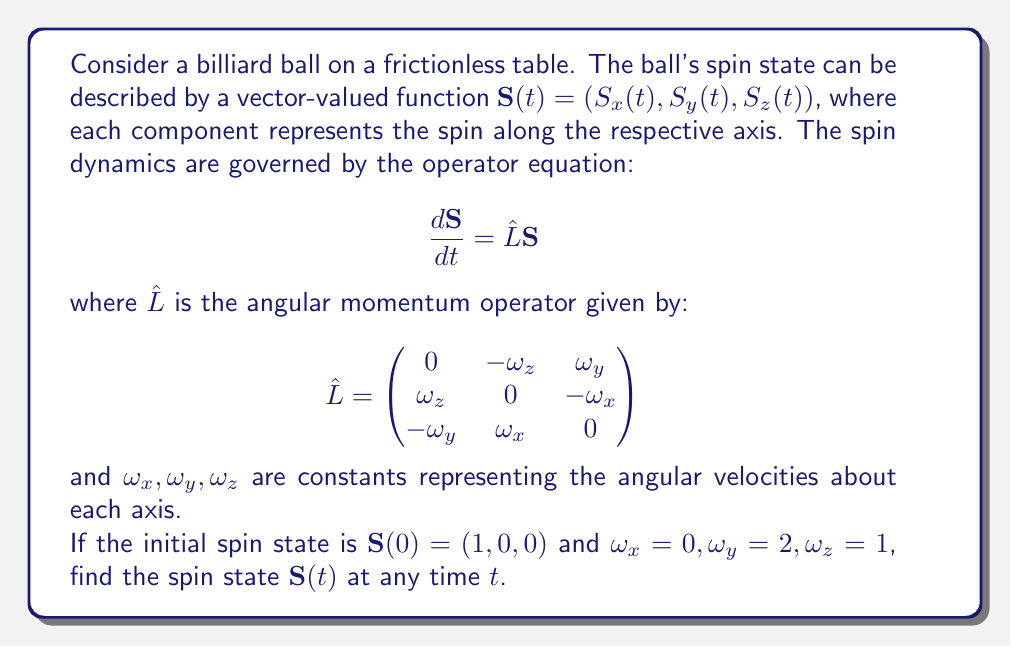Show me your answer to this math problem. To solve this problem, we need to follow these steps:

1) First, we need to write out the operator equation for our specific case:

   $$\frac{d}{dt}\begin{pmatrix} S_x \\ S_y \\ S_z \end{pmatrix} = \begin{pmatrix}
   0 & -1 & 2 \\
   1 & 0 & 0 \\
   -2 & 0 & 0
   \end{pmatrix}\begin{pmatrix} S_x \\ S_y \\ S_z \end{pmatrix}$$

2) This is a system of linear differential equations. The solution to such a system is given by the matrix exponential:

   $$\mathbf{S}(t) = e^{\hat{L}t}\mathbf{S}(0)$$

3) To compute the matrix exponential, we need to find the eigenvalues and eigenvectors of $\hat{L}$. The characteristic equation is:

   $$\det(\hat{L} - \lambda I) = -\lambda^3 - 5\lambda = 0$$

4) The eigenvalues are $\lambda_1 = 0, \lambda_2 = i\sqrt{5}, \lambda_3 = -i\sqrt{5}$.

5) The corresponding normalized eigenvectors are:

   $$\mathbf{v}_1 = \frac{1}{\sqrt{5}}(0, 2, 1)$$
   $$\mathbf{v}_2 = \frac{1}{\sqrt{10}}(2, -i\sqrt{5}, i\sqrt{5})$$
   $$\mathbf{v}_3 = \frac{1}{\sqrt{10}}(2, i\sqrt{5}, -i\sqrt{5})$$

6) We can now write the matrix exponential as:

   $$e^{\hat{L}t} = \mathbf{v}_1\mathbf{v}_1^T + e^{i\sqrt{5}t}\mathbf{v}_2\mathbf{v}_2^T + e^{-i\sqrt{5}t}\mathbf{v}_3\mathbf{v}_3^T$$

7) Multiplying this by the initial state $\mathbf{S}(0) = (1, 0, 0)$ and simplifying, we get:

   $$\mathbf{S}(t) = \begin{pmatrix}
   \cos(\sqrt{5}t) \\
   \frac{1}{\sqrt{5}}\sin(\sqrt{5}t) \\
   \frac{2}{\sqrt{5}}\sin(\sqrt{5}t)
   \end{pmatrix}$$

This is the spin state of the billiard ball at any time $t$.
Answer: $$\mathbf{S}(t) = \begin{pmatrix}
\cos(\sqrt{5}t) \\
\frac{1}{\sqrt{5}}\sin(\sqrt{5}t) \\
\frac{2}{\sqrt{5}}\sin(\sqrt{5}t)
\end{pmatrix}$$ 